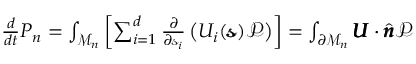<formula> <loc_0><loc_0><loc_500><loc_500>\begin{array} { r } { \frac { d } { d t } P _ { n } = \int _ { \mathcal { M } _ { n } } \left [ \sum _ { i = 1 } ^ { d } \frac { \partial } { \partial \ m a t h s c r { s } _ { i } } \left ( U _ { i } ( \pm b { \ m a t h s c r { s } } ) \mathcal { P } \right ) \right ] = \int _ { \partial \mathcal { M } _ { n } } \pm b { U } \cdot \hat { \pm b { n } } \mathcal { P } } \end{array}</formula> 